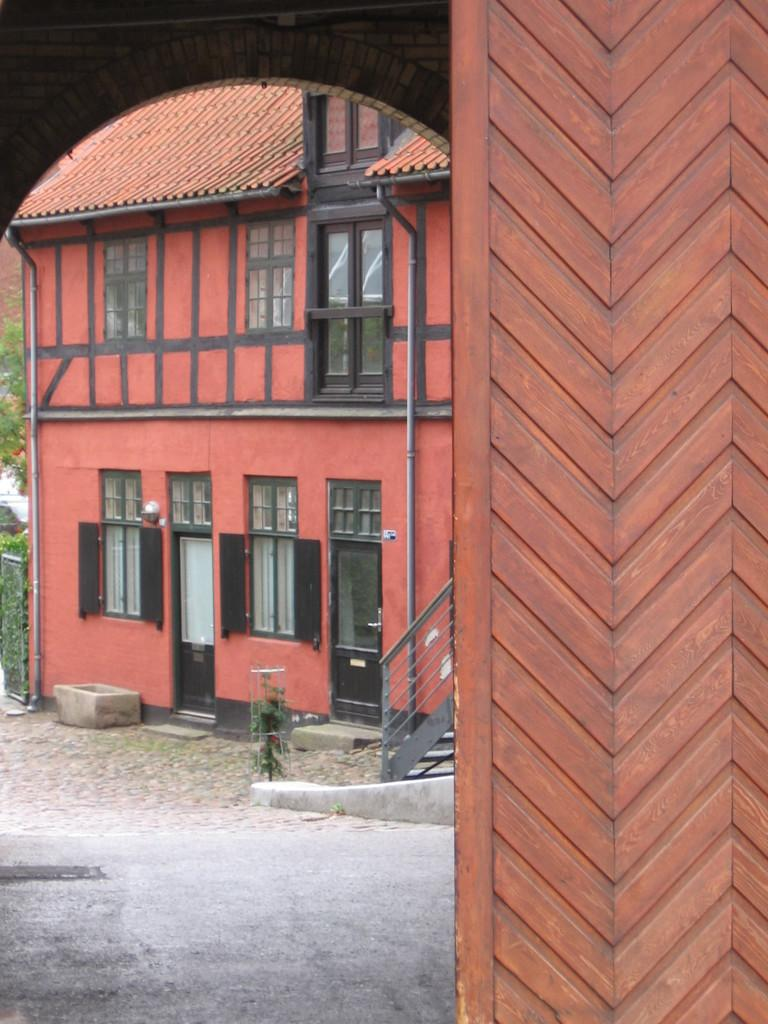What is the color of the building in the image? The building in the image is red. What are the main features of the building? The building has doors and windows. What color is the rooftop of the building? The rooftop of the building is red. How is the entrance to the building made? The entrance to the building is made of wood. Are there any firemen visible in the image? There is no indication of firemen in the image. What type of punishment is being administered in the image? There is no punishment being administered in the image. 